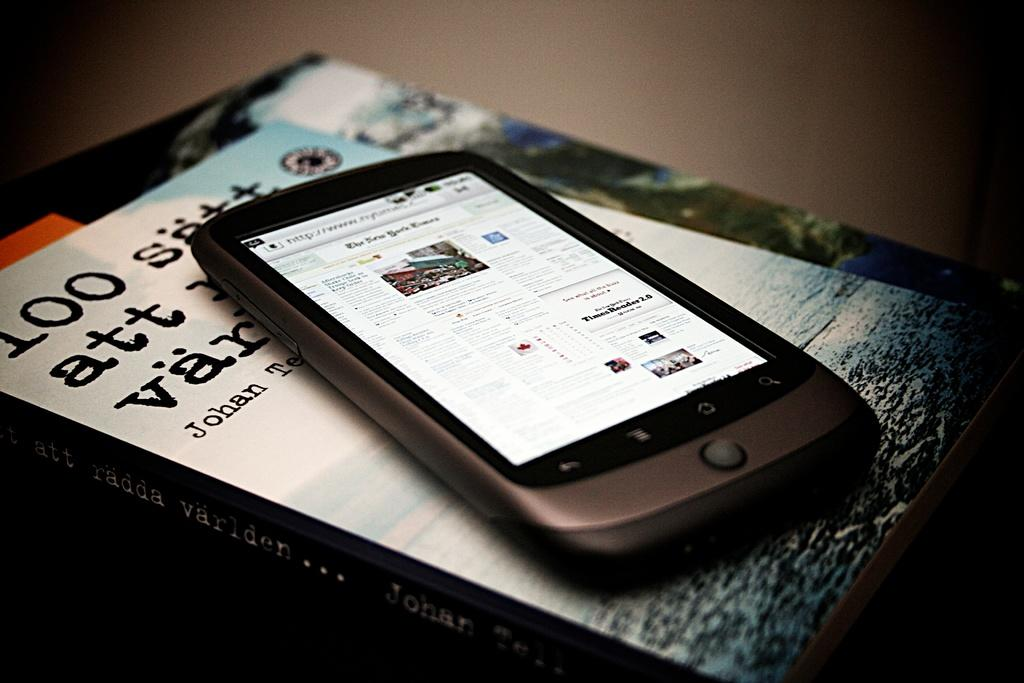Provide a one-sentence caption for the provided image. A black cell phone displaying a New York Times page sitting on top of a book. 